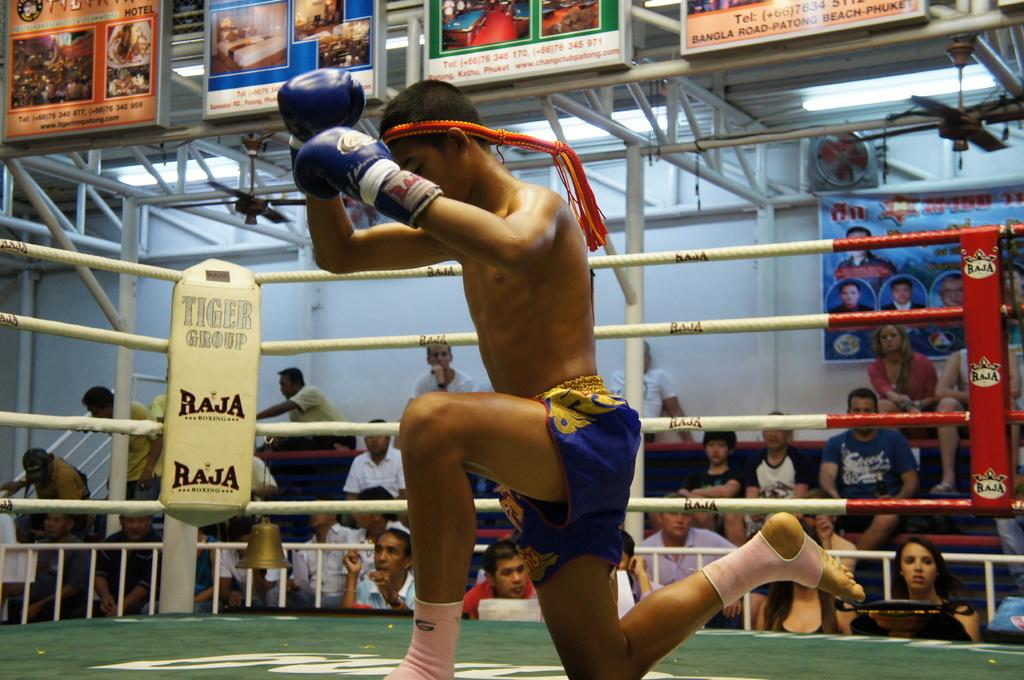Provide a one-sentence caption for the provided image. The corner of a boxing ring states Tiger Group. 